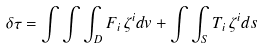<formula> <loc_0><loc_0><loc_500><loc_500>\delta \tau = \int \int \int _ { D } F _ { i } \, \zeta ^ { i } d v + \int \int _ { S } T _ { i } \, \zeta ^ { i } d { s }</formula> 